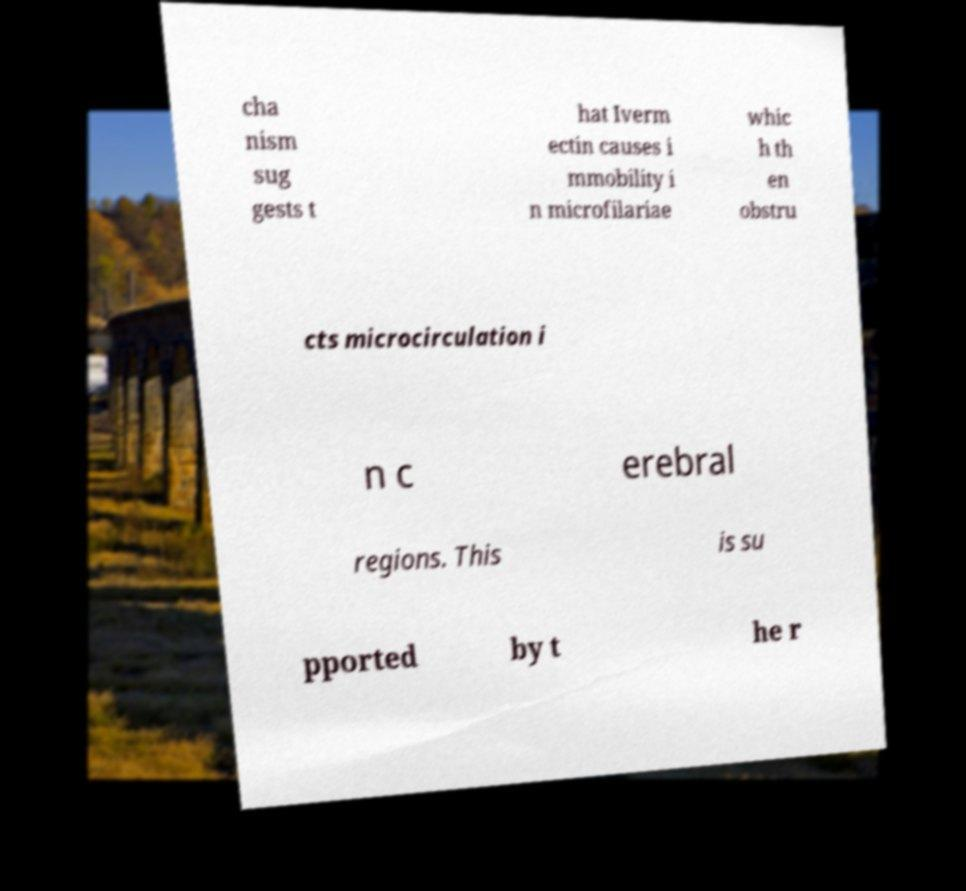Please identify and transcribe the text found in this image. cha nism sug gests t hat Iverm ectin causes i mmobility i n microfilariae whic h th en obstru cts microcirculation i n c erebral regions. This is su pported by t he r 